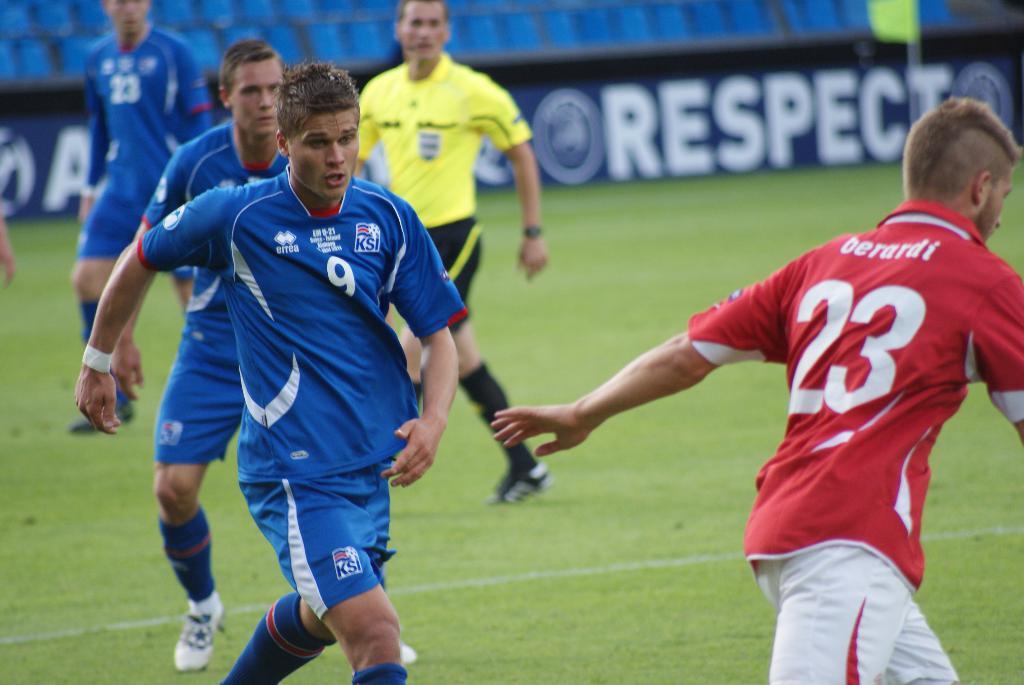What is the player number in red?
Offer a very short reply. 23. 